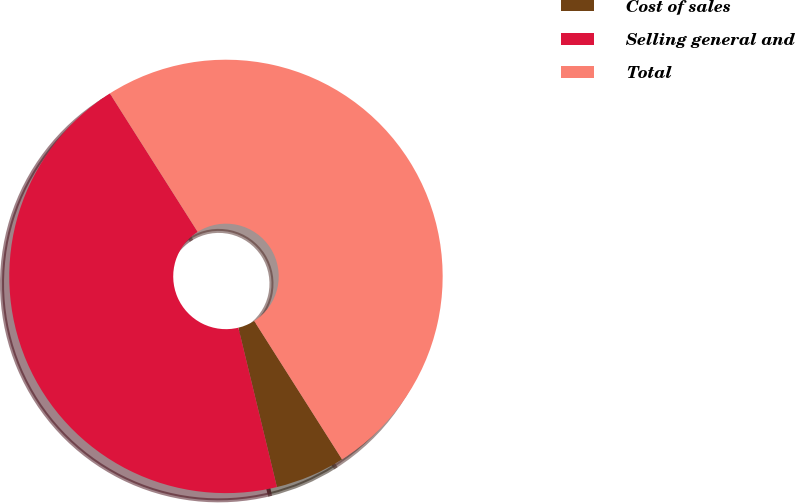Convert chart. <chart><loc_0><loc_0><loc_500><loc_500><pie_chart><fcel>Cost of sales<fcel>Selling general and<fcel>Total<nl><fcel>5.22%<fcel>44.78%<fcel>50.0%<nl></chart> 